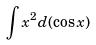<formula> <loc_0><loc_0><loc_500><loc_500>\int x ^ { 2 } d ( \cos x )</formula> 